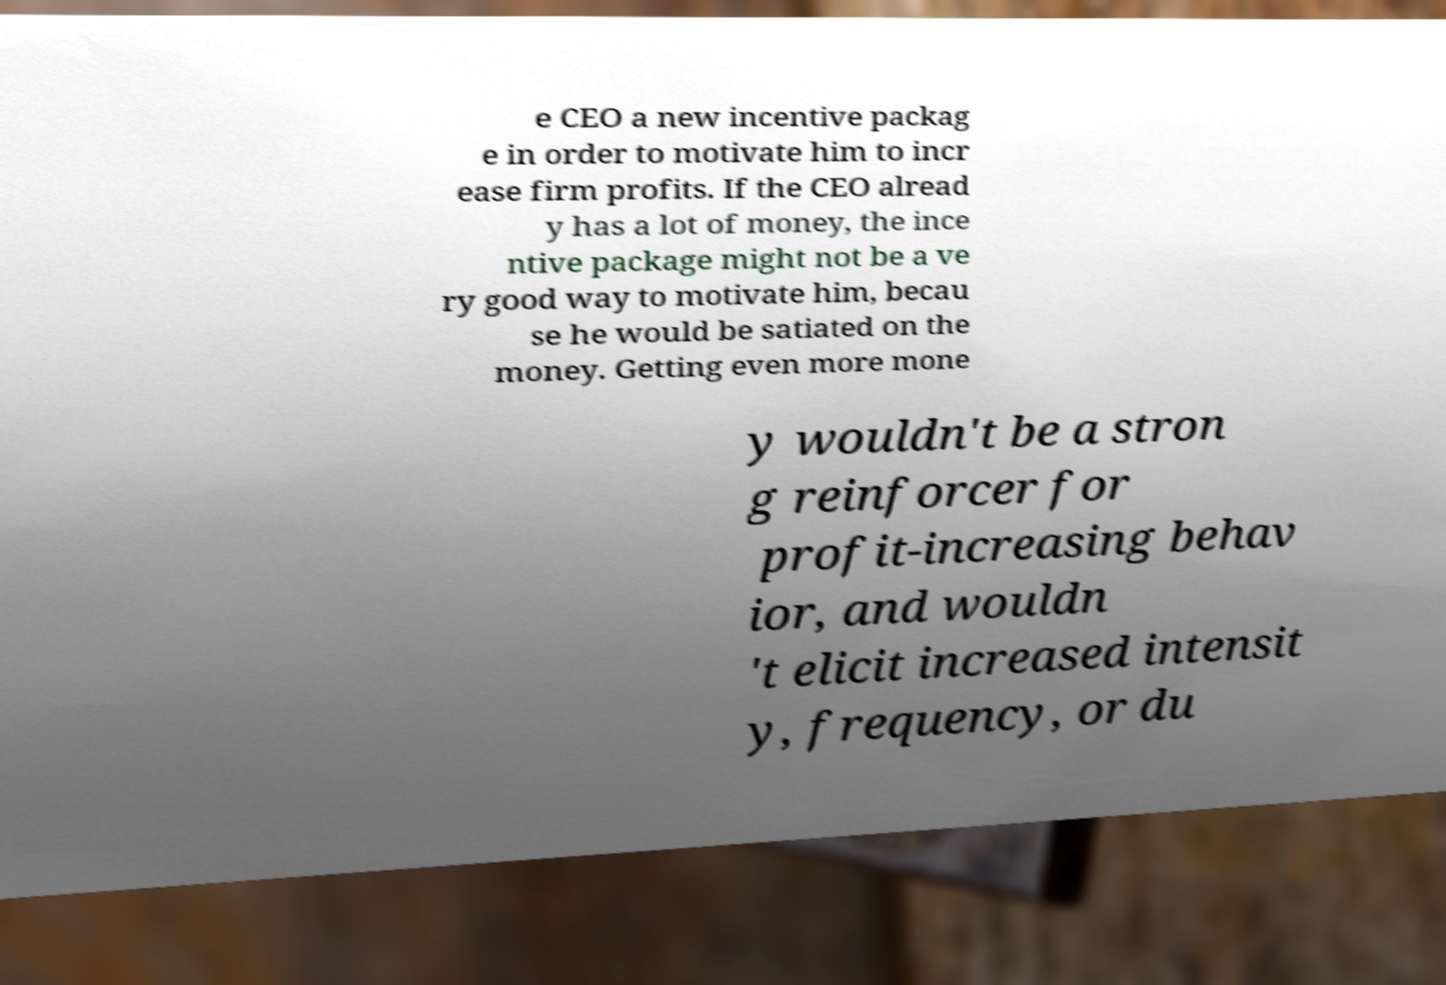What messages or text are displayed in this image? I need them in a readable, typed format. e CEO a new incentive packag e in order to motivate him to incr ease firm profits. If the CEO alread y has a lot of money, the ince ntive package might not be a ve ry good way to motivate him, becau se he would be satiated on the money. Getting even more mone y wouldn't be a stron g reinforcer for profit-increasing behav ior, and wouldn 't elicit increased intensit y, frequency, or du 